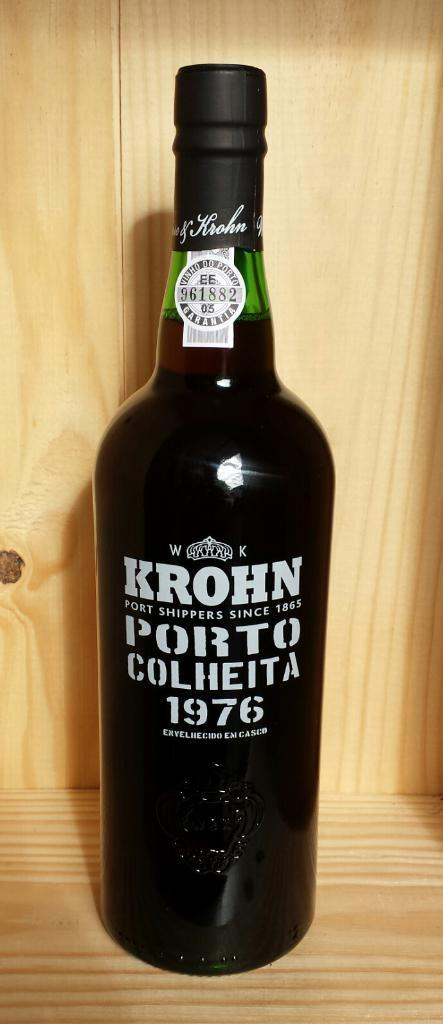<image>
Relay a brief, clear account of the picture shown. An alcoholic beverage by Krohn was made in 1976 